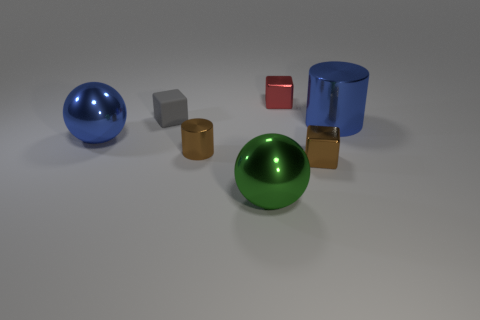Is the small red thing the same shape as the matte thing?
Your response must be concise. Yes. What is the color of the rubber block?
Your response must be concise. Gray. What number of other things are there of the same material as the tiny red block
Your answer should be compact. 5. What number of yellow things are either large metal balls or big matte objects?
Your answer should be compact. 0. There is a large blue metallic thing on the left side of the small gray cube; is its shape the same as the tiny red metal object to the right of the tiny rubber cube?
Offer a terse response. No. There is a big cylinder; does it have the same color as the metallic cylinder that is to the left of the large metallic cylinder?
Offer a terse response. No. There is a tiny thing that is behind the gray matte block; is its color the same as the matte block?
Offer a very short reply. No. What number of things are either tiny green cylinders or balls on the left side of the large green metallic object?
Provide a succinct answer. 1. There is a cube that is both in front of the red block and behind the big cylinder; what material is it made of?
Offer a terse response. Rubber. What material is the large blue object that is left of the large green ball?
Make the answer very short. Metal. 